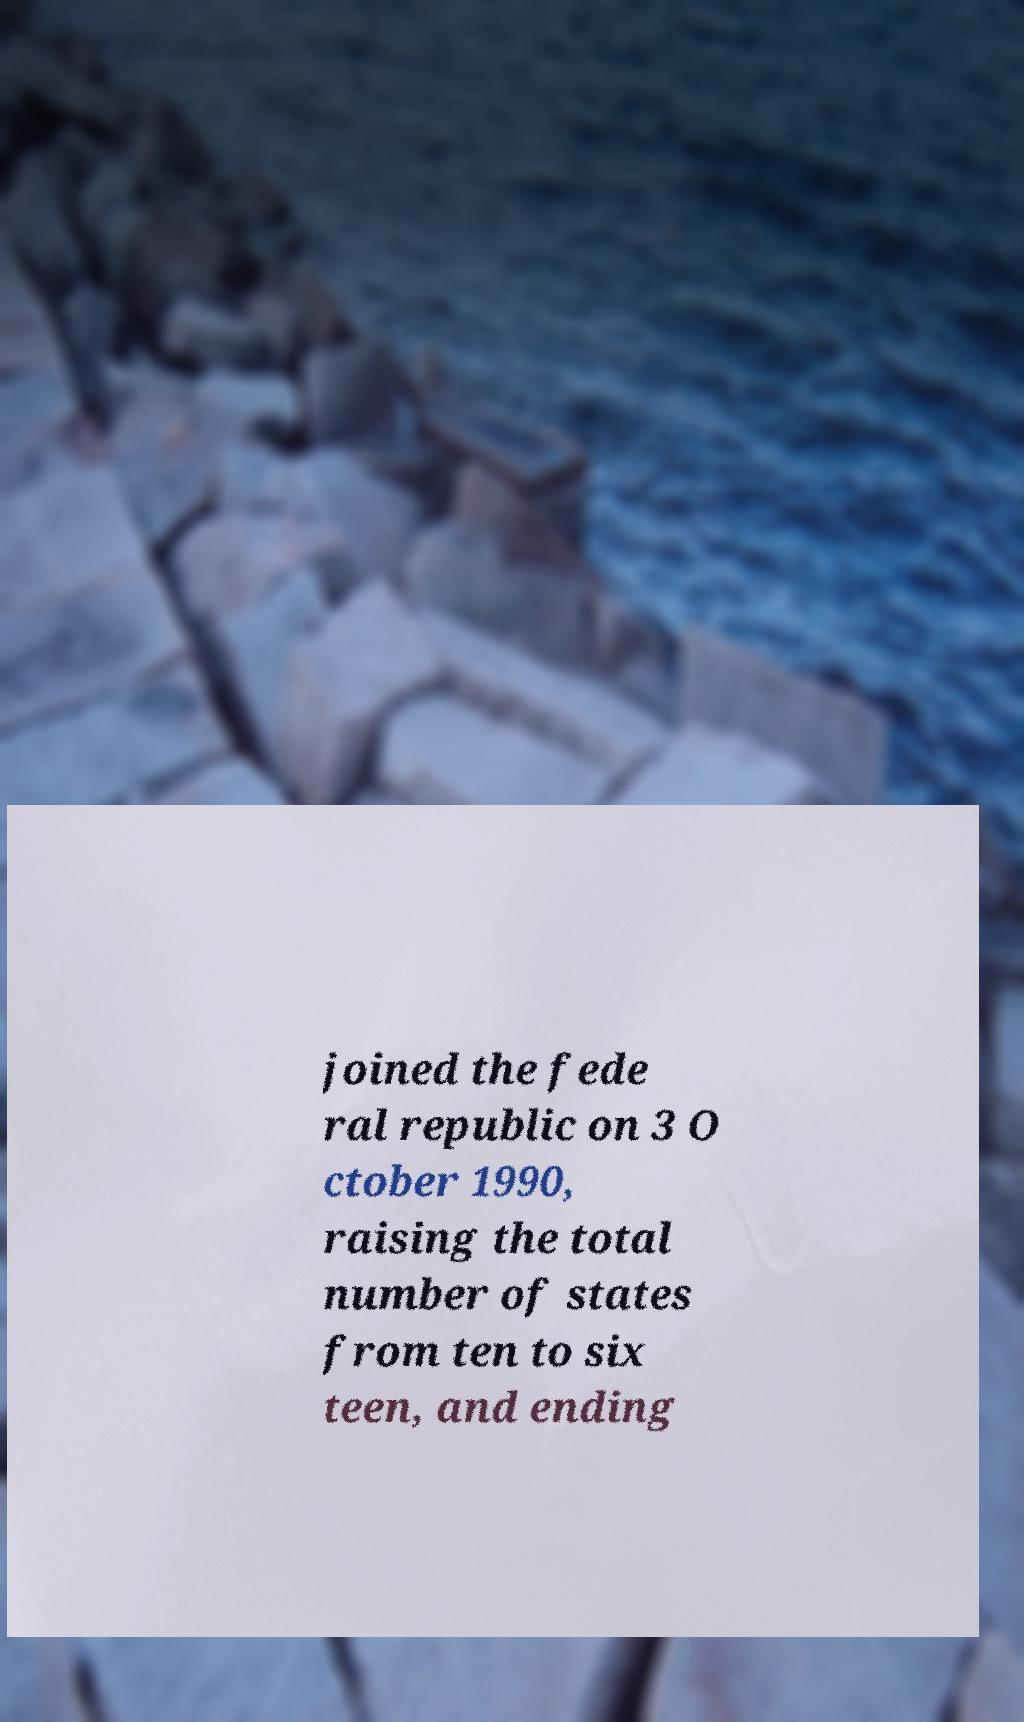Could you assist in decoding the text presented in this image and type it out clearly? joined the fede ral republic on 3 O ctober 1990, raising the total number of states from ten to six teen, and ending 